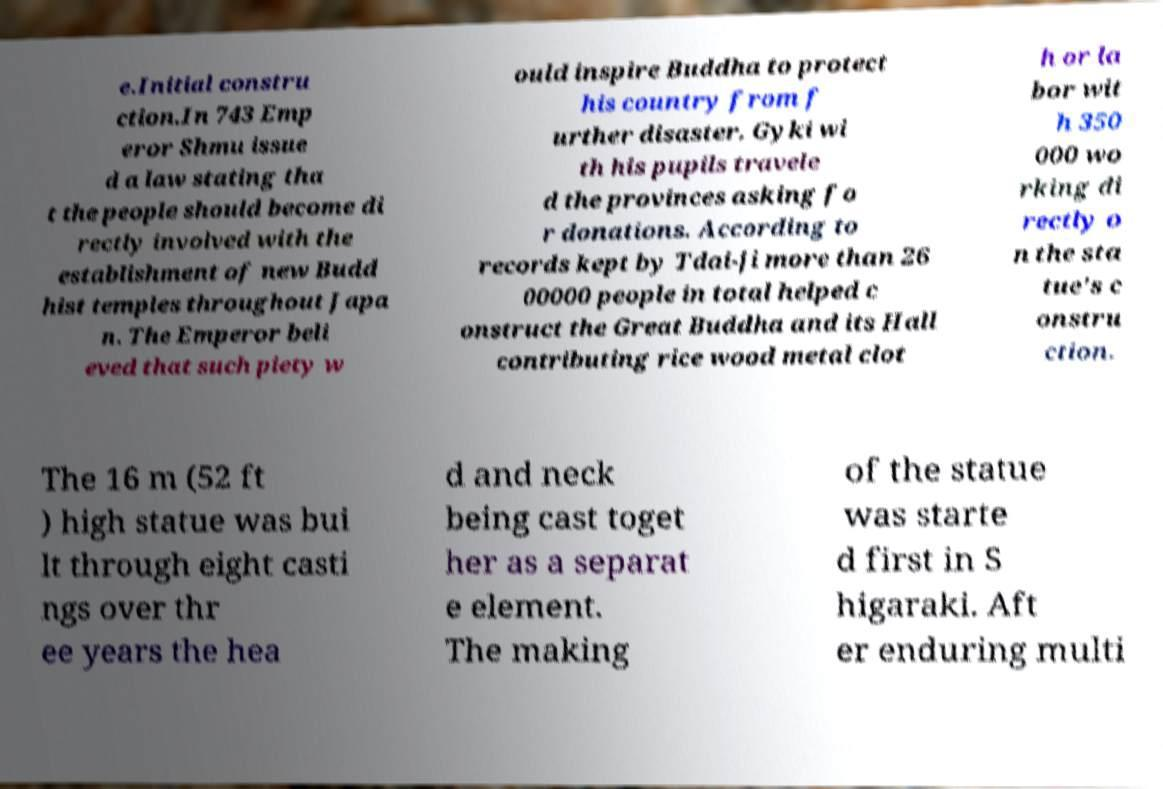For documentation purposes, I need the text within this image transcribed. Could you provide that? e.Initial constru ction.In 743 Emp eror Shmu issue d a law stating tha t the people should become di rectly involved with the establishment of new Budd hist temples throughout Japa n. The Emperor beli eved that such piety w ould inspire Buddha to protect his country from f urther disaster. Gyki wi th his pupils travele d the provinces asking fo r donations. According to records kept by Tdai-ji more than 26 00000 people in total helped c onstruct the Great Buddha and its Hall contributing rice wood metal clot h or la bor wit h 350 000 wo rking di rectly o n the sta tue's c onstru ction. The 16 m (52 ft ) high statue was bui lt through eight casti ngs over thr ee years the hea d and neck being cast toget her as a separat e element. The making of the statue was starte d first in S higaraki. Aft er enduring multi 